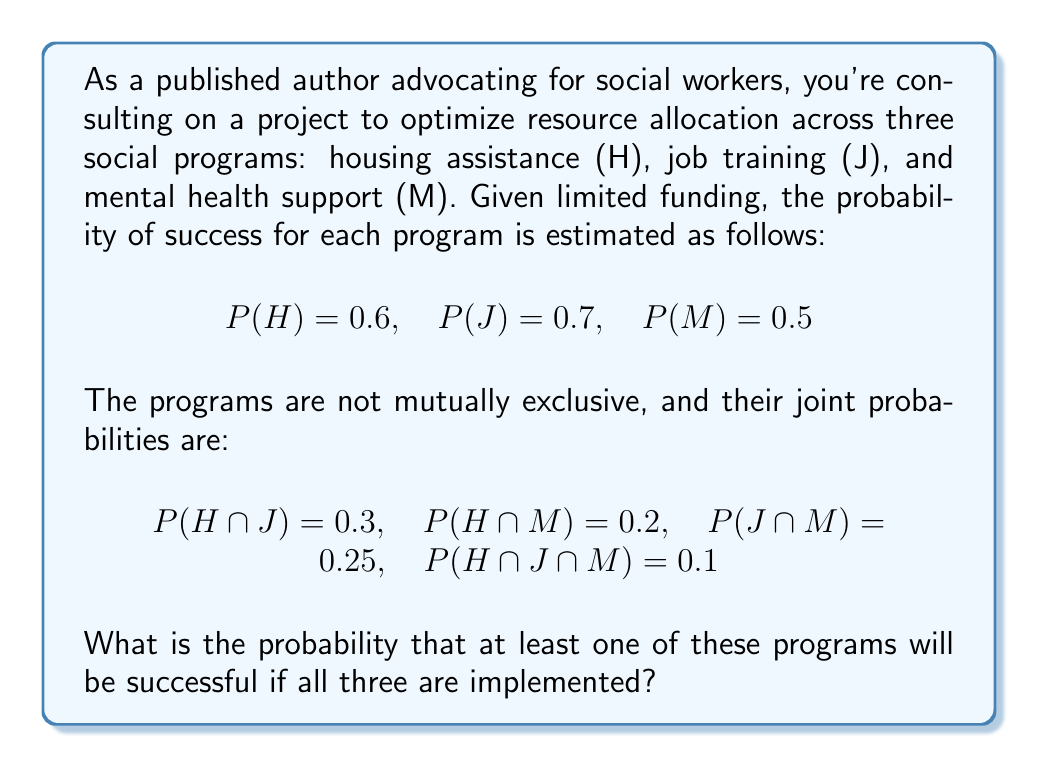Solve this math problem. To solve this problem, we'll use the inclusion-exclusion principle for three events. The probability of at least one event occurring is equal to the sum of the probabilities of each event, minus the probabilities of their intersections, plus the probability of all three intersecting.

Let's define S as the event that at least one program is successful. We want to find P(S).

Step 1: Apply the inclusion-exclusion principle:
$$P(S) = P(H ∪ J ∪ M) = P(H) + P(J) + P(M) - P(H ∩ J) - P(H ∩ M) - P(J ∩ M) + P(H ∩ J ∩ M)$$

Step 2: Substitute the given probabilities:
$$P(S) = 0.6 + 0.7 + 0.5 - 0.3 - 0.2 - 0.25 + 0.1$$

Step 3: Calculate the result:
$$P(S) = 1.8 - 0.75 + 0.1 = 1.15$$

Step 4: Interpret the result:
Since probabilities cannot exceed 1, we conclude that the probability of at least one program being successful is 1, or 100%.

This result indicates that implementing all three programs guarantees at least one will be successful, highlighting the importance of a diverse approach to social support.
Answer: 1 (or 100%) 